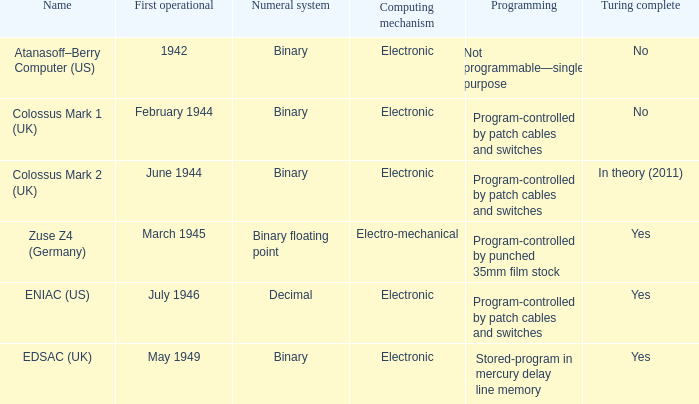What's the turing complete with name being atanasoff–berry computer (us) No. 